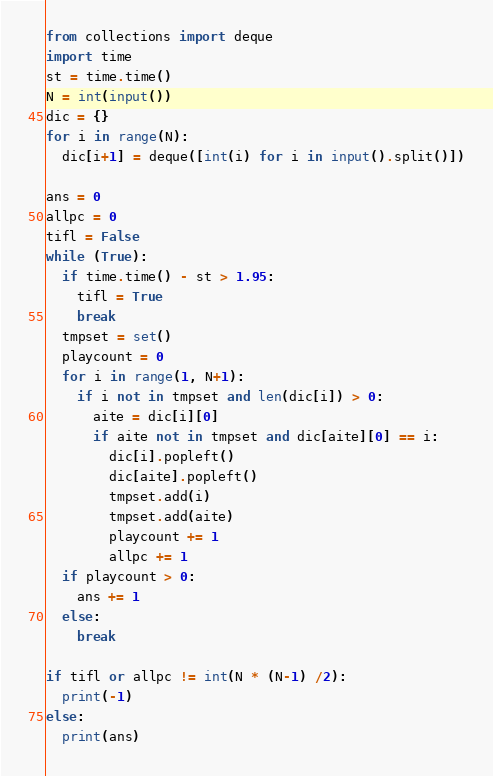Convert code to text. <code><loc_0><loc_0><loc_500><loc_500><_Python_>from collections import deque
import time
st = time.time()
N = int(input())
dic = {}
for i in range(N):
  dic[i+1] = deque([int(i) for i in input().split()])

ans = 0
allpc = 0
tifl = False
while (True):
  if time.time() - st > 1.95:
    tifl = True
    break
  tmpset = set()
  playcount = 0
  for i in range(1, N+1):
    if i not in tmpset and len(dic[i]) > 0:
      aite = dic[i][0]
      if aite not in tmpset and dic[aite][0] == i:
        dic[i].popleft()
        dic[aite].popleft()
        tmpset.add(i)
        tmpset.add(aite)
        playcount += 1
        allpc += 1
  if playcount > 0:
    ans += 1
  else:
    break

if tifl or allpc != int(N * (N-1) /2):
  print(-1)
else:
  print(ans)
</code> 